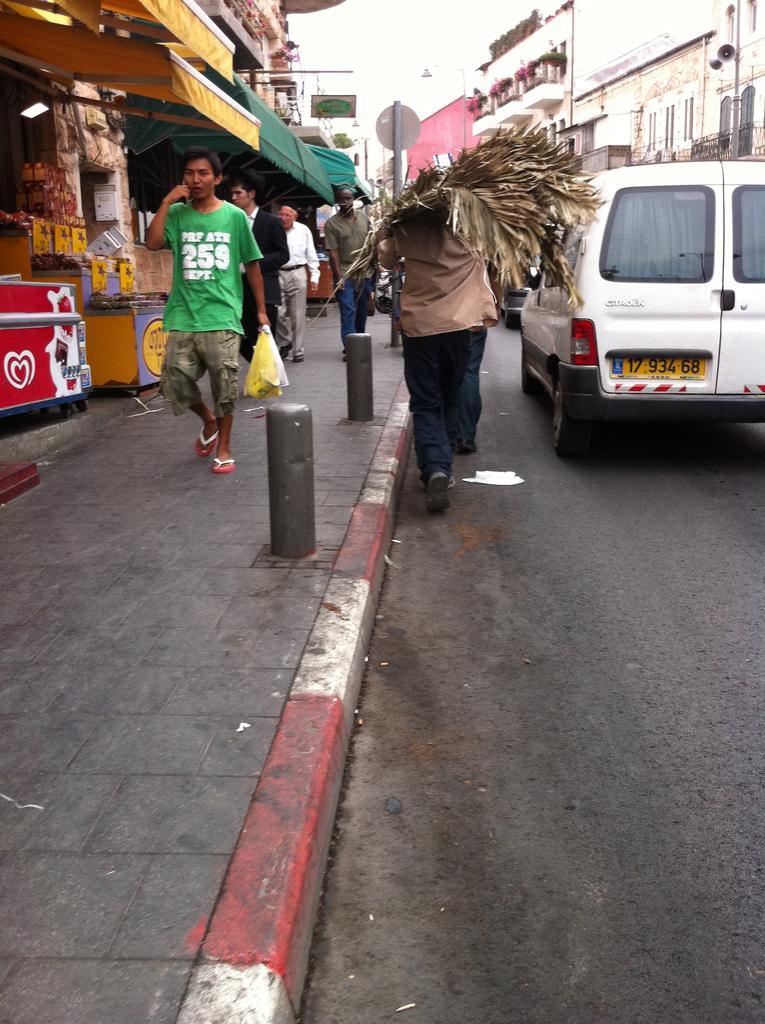Could you give a brief overview of what you see in this image? In this image we can see a person holding the dried leaves and walking on the road. We can also see the vehicles. On the left, we can see the stalls and also some people walking. In the background, we can see the buildings, sign board and also the sky. 